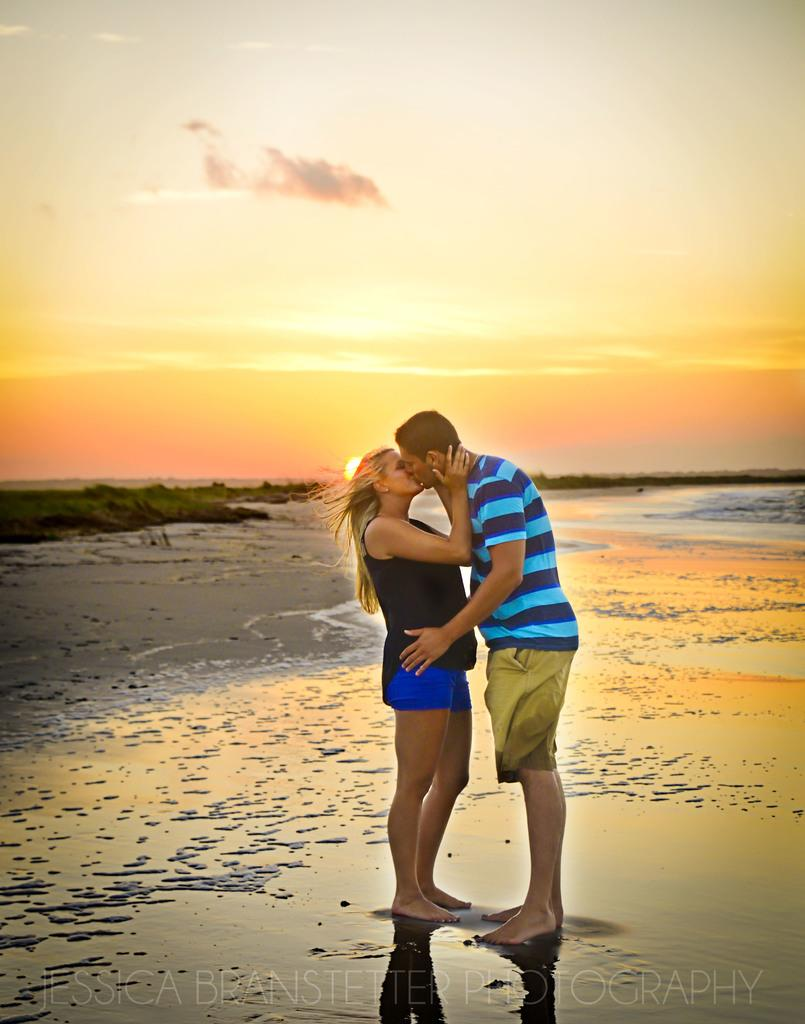How many people are in the image? There are two people in the image. What is visible in the image besides the people? Water, trees in the background, and the sky are visible in the image. What can be seen in the sky? The sun and clouds are present in the sky. What type of ornament is hanging from the tree in the image? There is no ornament hanging from the tree in the image; only trees and the sky are visible. Can you see a playground in the image? There is no playground present in the image. 